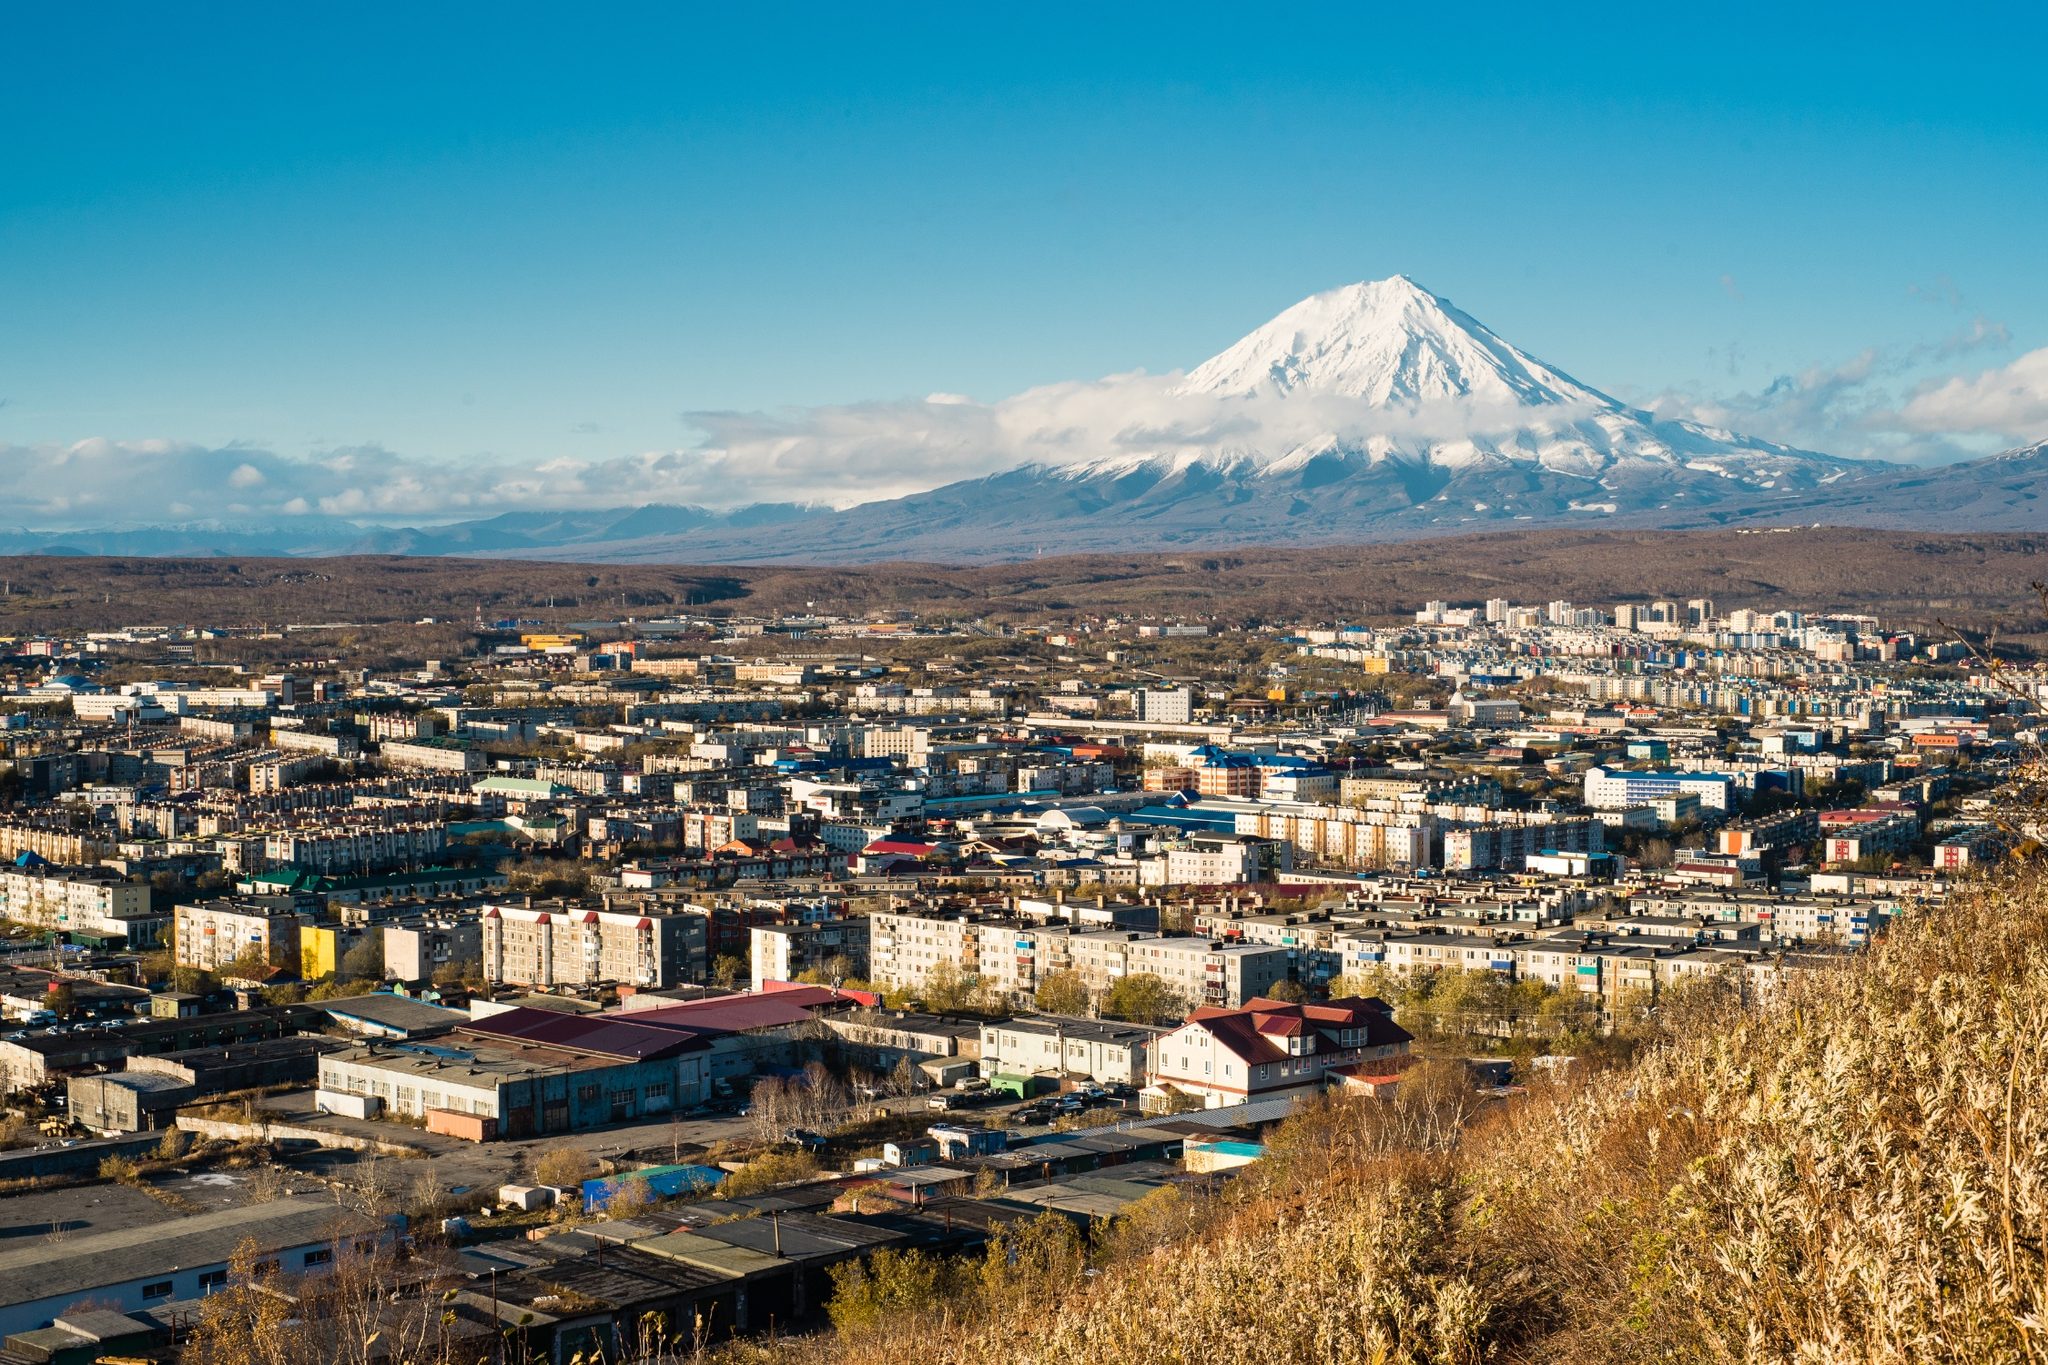If you could add any futuristic technology to this city to improve the daily lives of its residents, what would it be and why? If I could introduce a futuristic technology to Petropavlovsk-Kamchatsky, it would be advanced geothermal energy systems. Given the volcanic activity in the region, geothermal energy could be harnessed efficiently to provide a sustainable, clean, and virtually unlimited source of power for the entire city. This technology would not only reduce the city's carbon footprint but also ensure energy independence and stability. In addition to power generation, geothermal systems could be used for heating purposes, drastically reducing energy costs during the harsh winter months. Implementing such technology would enhance the quality of life for residents, promote economic development, and serve as a model for sustainable living in other volcanic regions around the world. How might this city look like 100 years into the future? One hundred years into the future, Petropavlovsk-Kamchatsky may transform into a beacon of sustainable urban living, seamlessly blending the natural and built environments. Smart buildings, powered entirely by geothermal and renewable energy, dot the landscape, with vertical gardens and green roofs integrated into their design. Advanced transportation networks, comprising electric and autonomous vehicles, ensure efficient and eco-friendly mobility for all residents. The city streets are lined with green spaces, parks, and recreational areas, promoting a harmonious community lifestyle. Technological advancements allow for real-time monitoring and management of volcanic activity, ensuring the safety of the populace through sophisticated early-warning systems. The Koryaksky volcano continues to stand as an awe-inspiring natural monument, its pristine snow-capped peak a testament to the city's respect for nature. The educational institutions in the city excel in earth sciences and sustainable technologies, attracting scholars and innovators from around the globe. Petropavlovsk-Kamchatsky stands as a shining example of how humanity can thrive in conjunction with the wonders and challenges of nature. 